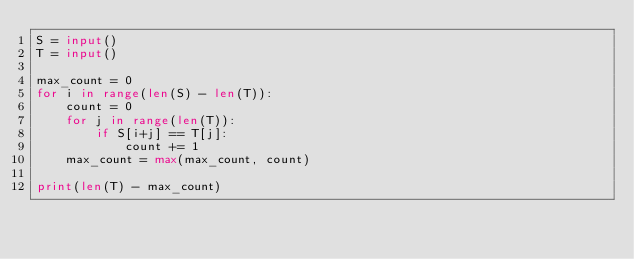<code> <loc_0><loc_0><loc_500><loc_500><_Python_>S = input()
T = input()

max_count = 0
for i in range(len(S) - len(T)):
    count = 0
    for j in range(len(T)):
        if S[i+j] == T[j]:
            count += 1
    max_count = max(max_count, count)
    
print(len(T) - max_count)</code> 